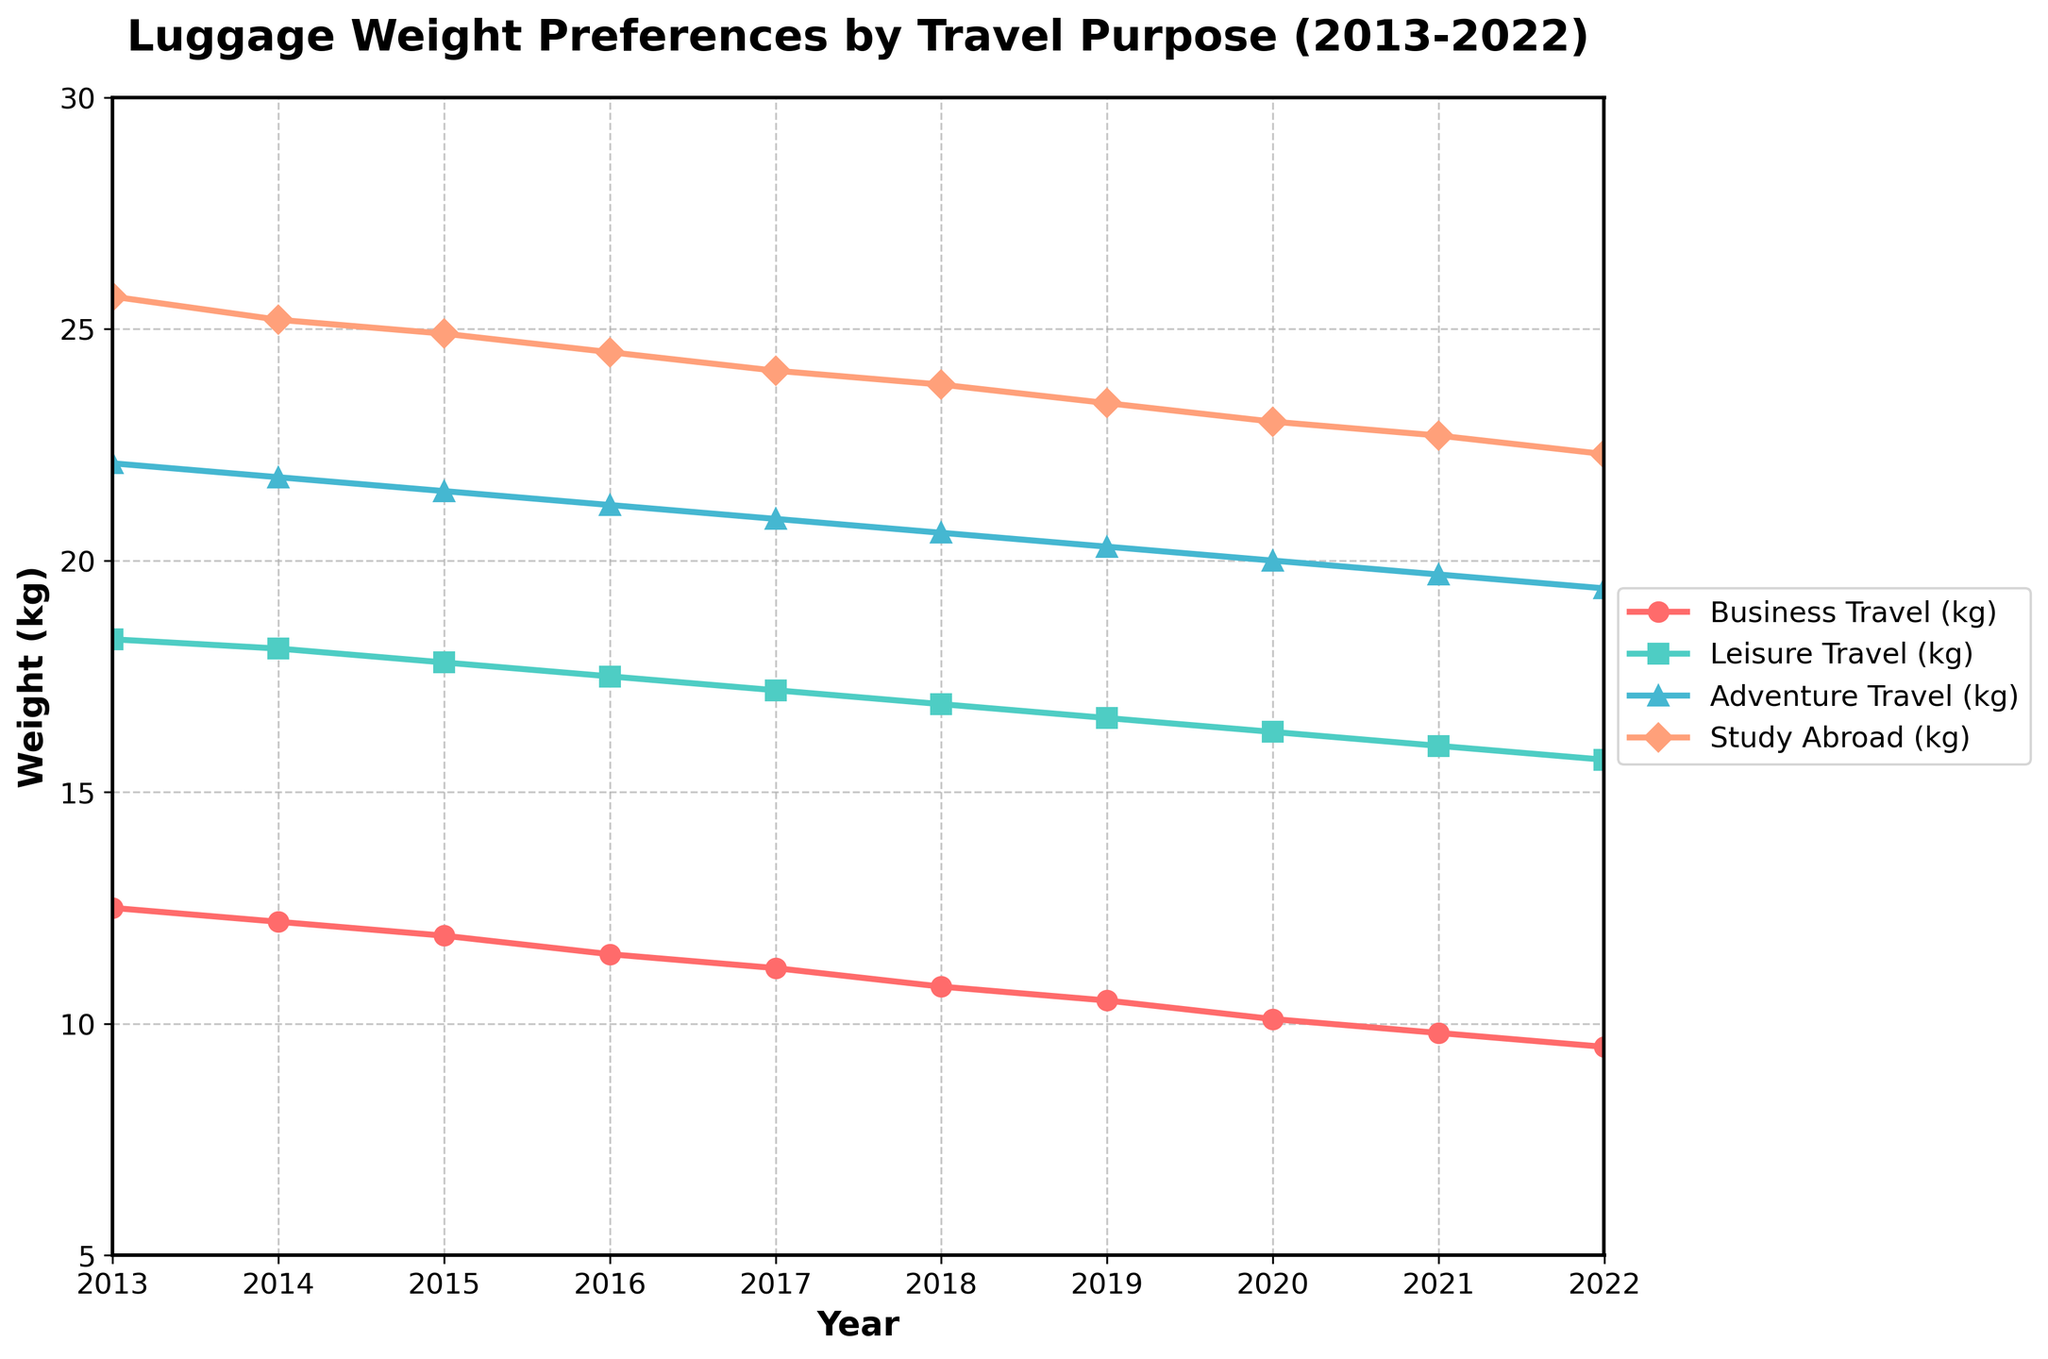What's the trend in luggage weight for Business Travel from 2013 to 2022? The weight decreases steadily from 12.5 kg in 2013 to 9.5 kg in 2022. This is evident by observing the downward slope of the line for Business Travel from left to right on the graph.
Answer: Decreasing Which travel purpose shows the highest luggage weight in 2017? The graph shows that Study Abroad has the highest luggage weight in 2017. By comparing the y-values of the lines, the Study Abroad line (24.1 kg) is at a higher position than the others.
Answer: Study Abroad What is the average luggage weight for Leisure Travel over the 10 years? Add up the weights for Leisure Travel from each year and divide by the number of years: (18.3 + 18.1 + 17.8 + 17.5 + 17.2 + 16.9 + 16.6 + 16.3 + 16.0 + 15.7) / 10. The sum is 170.4, and the average is 170.4 / 10.
Answer: 17.04 kg How does the weight for Adventure Travel in 2022 compare to Business Travel in 2018? The weight for Adventure Travel in 2022 is 19.4 kg and for Business Travel in 2018 is 10.8 kg. The Adventure Travel luggage is heavier.
Answer: Adventure Travel is heavier Between 2013 and 2019, which travel purposes have a consistent downward trend in luggage weight? By visually inspecting the lines from 2013 to 2019, Business Travel, Leisure Travel, and Study Abroad show consistent downward trends. Adventure Travel has slight fluctuations but overall a downward trend.
Answer: Business Travel, Leisure Travel, Study Abroad What year did Business Travel luggage weight first drop below 10 kg? Look for the first year where the Business Travel line drops below the 10 kg mark on the y-axis. It happens in 2021.
Answer: 2021 Which travel purpose had the smallest percentage decrease in luggage weight from 2013 to 2022? Calculate the percentage decrease for each category. Business Travel: ((12.5 - 9.5) / 12.5) * 100 = 24%, Leisure Travel: ((18.3 - 15.7) / 18.3) * 100 = 14.21%, Adventure Travel: ((22.1 - 19.4) / 22.1) * 100 = 12.22%, Study Abroad: ((25.7 - 22.3) / 25.7) * 100 = 13.24%. Adventure Travel had the smallest percentage decrease.
Answer: Adventure Travel How does the shape of the Study Abroad line compare to the other lines? The Study Abroad line has a steady decline similar to the other lines but starts and ends at higher values, indicating generally heavier luggage weights.
Answer: Consistent, higher values If the trend continues, which travel purpose is likely to have the lightest luggage weight in the next few years? Observing the trends, Business Travel is consistently decreasing and is already the lowest in 2022. It is likely to remain the lightest if trends continue.
Answer: Business Travel 